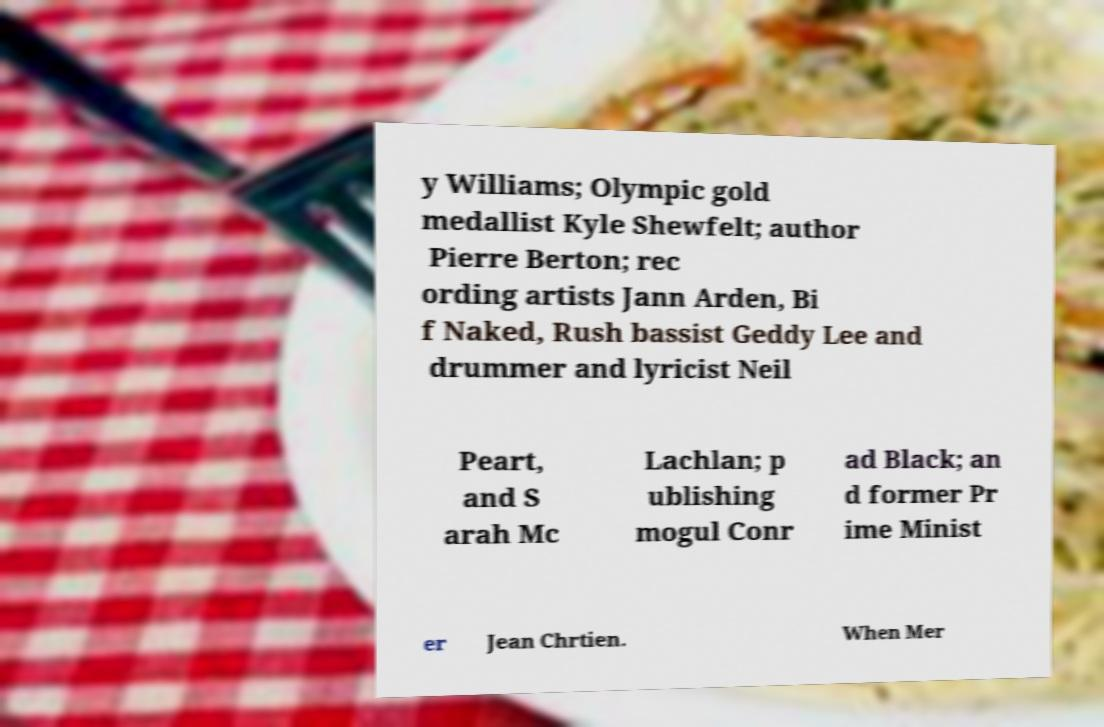What messages or text are displayed in this image? I need them in a readable, typed format. y Williams; Olympic gold medallist Kyle Shewfelt; author Pierre Berton; rec ording artists Jann Arden, Bi f Naked, Rush bassist Geddy Lee and drummer and lyricist Neil Peart, and S arah Mc Lachlan; p ublishing mogul Conr ad Black; an d former Pr ime Minist er Jean Chrtien. When Mer 